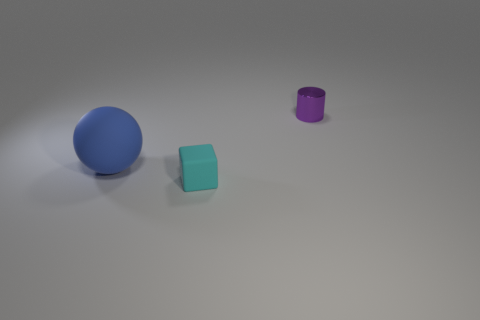Are there any other things that are the same size as the rubber ball?
Ensure brevity in your answer.  No. How many tiny matte things have the same shape as the large matte thing?
Your answer should be compact. 0. What is the color of the thing that is on the right side of the big blue matte ball and behind the small cyan cube?
Offer a very short reply. Purple. How many purple metal things are there?
Provide a short and direct response. 1. Does the metal cylinder have the same size as the blue rubber sphere?
Make the answer very short. No. Are there any metal cylinders that have the same color as the matte sphere?
Give a very brief answer. No. Is the shape of the tiny thing left of the tiny cylinder the same as  the large blue object?
Provide a short and direct response. No. What number of objects have the same size as the ball?
Provide a succinct answer. 0. How many blue matte objects are in front of the tiny thing in front of the small purple metallic cylinder?
Keep it short and to the point. 0. Do the tiny thing that is in front of the small cylinder and the blue sphere have the same material?
Your answer should be compact. Yes. 